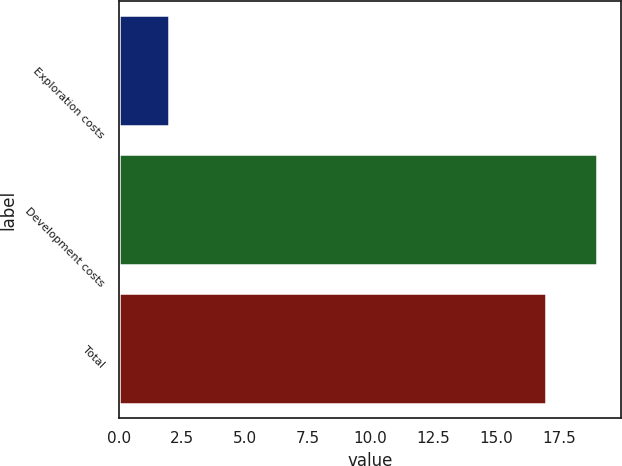<chart> <loc_0><loc_0><loc_500><loc_500><bar_chart><fcel>Exploration costs<fcel>Development costs<fcel>Total<nl><fcel>2<fcel>19<fcel>17<nl></chart> 